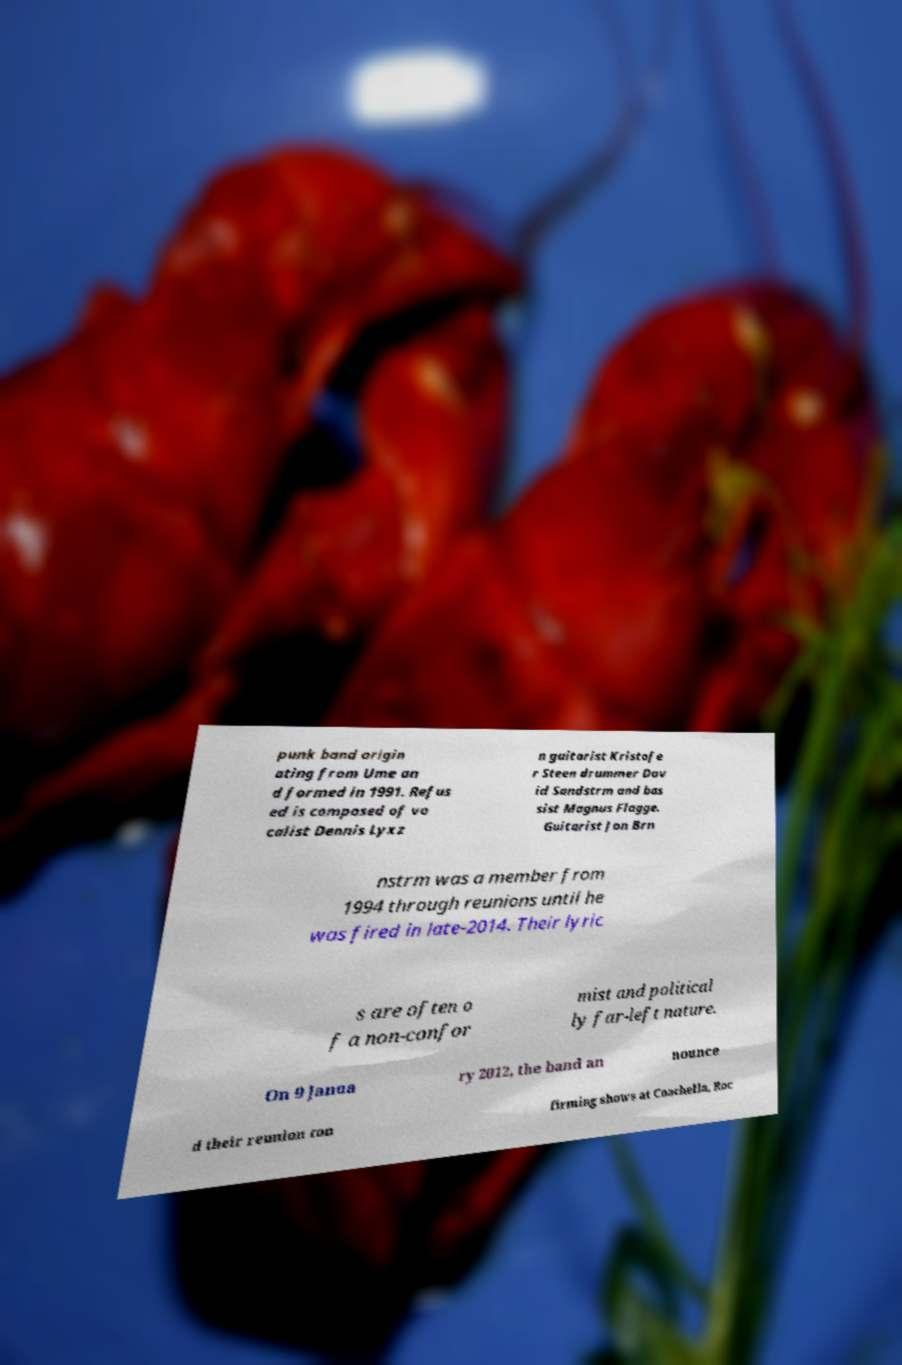For documentation purposes, I need the text within this image transcribed. Could you provide that? punk band origin ating from Ume an d formed in 1991. Refus ed is composed of vo calist Dennis Lyxz n guitarist Kristofe r Steen drummer Dav id Sandstrm and bas sist Magnus Flagge. Guitarist Jon Brn nstrm was a member from 1994 through reunions until he was fired in late-2014. Their lyric s are often o f a non-confor mist and political ly far-left nature. On 9 Janua ry 2012, the band an nounce d their reunion con firming shows at Coachella, Roc 